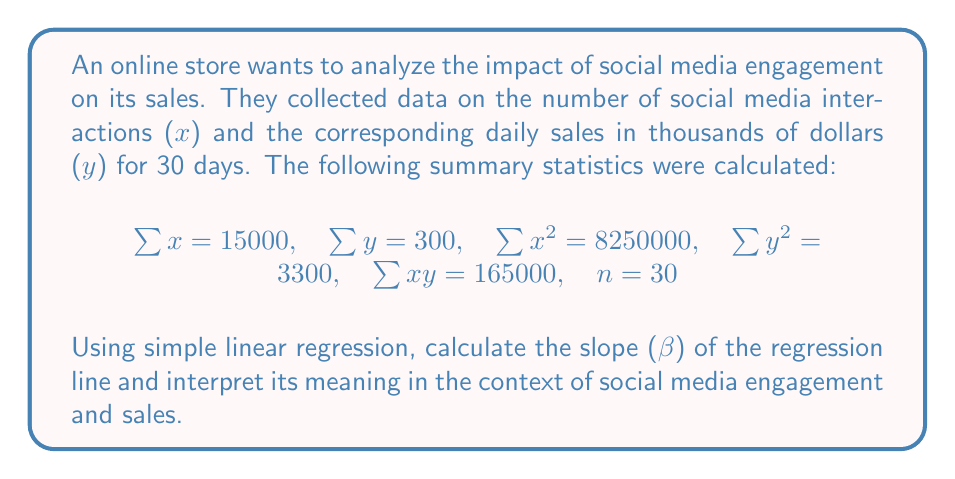What is the answer to this math problem? To solve this problem, we'll use the formula for the slope (β) in simple linear regression:

$$\beta = \frac{n\sum xy - \sum x \sum y}{n\sum x^2 - (\sum x)^2}$$

Let's substitute the given values:

$$\beta = \frac{30(165000) - (15000)(300)}{30(8250000) - (15000)^2}$$

Simplifying:
$$\beta = \frac{4950000 - 4500000}{247500000 - 225000000}$$

$$\beta = \frac{450000}{22500000}$$

$$\beta = 0.02$$

Interpretation:
The slope (β) represents the change in the dependent variable (y) for a one-unit change in the independent variable (x). In this context, β = 0.02 means that for every additional social media interaction, the daily sales are expected to increase by $20 (0.02 * 1000, since sales are in thousands of dollars).
Answer: β = 0.02, indicating that each additional social media interaction is associated with an expected increase of $20 in daily sales. 